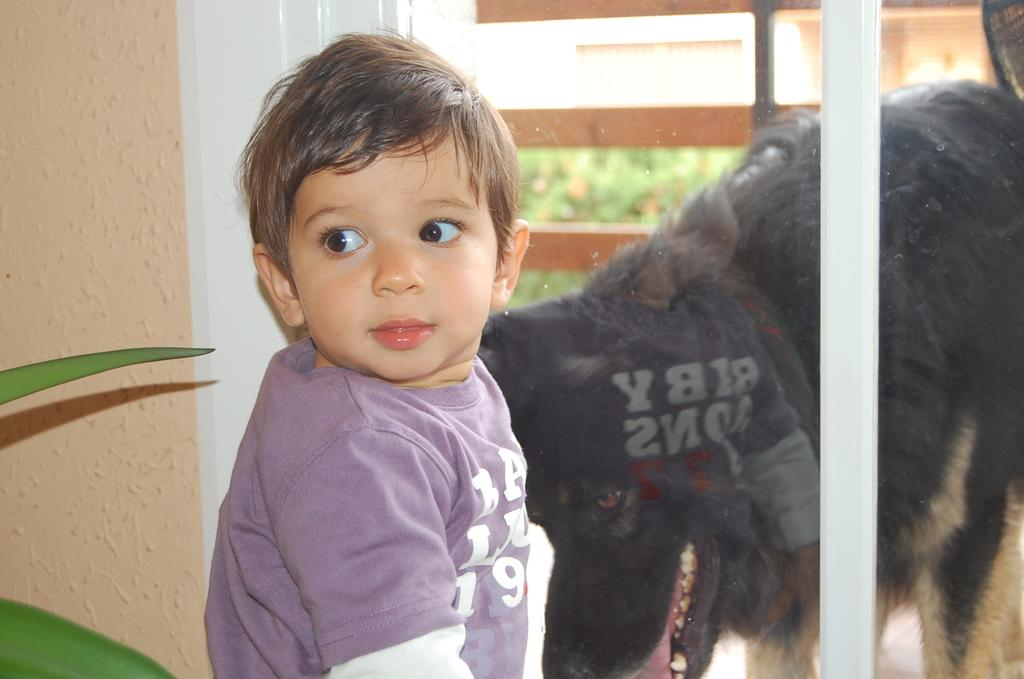What is the main subject of the image? There is a kid in the image. Are there any animals present in the image? Yes, there is a dog in the image. What is located beside the kid? There is a plant beside the kid. What type of container is visible in the image? There is a glass visible in the image. What year is depicted in the image? The image does not depict a specific year; it is a photograph of a kid, a dog, a plant, and a glass. What type of sheet is visible in the image? There is no sheet present in the image. 